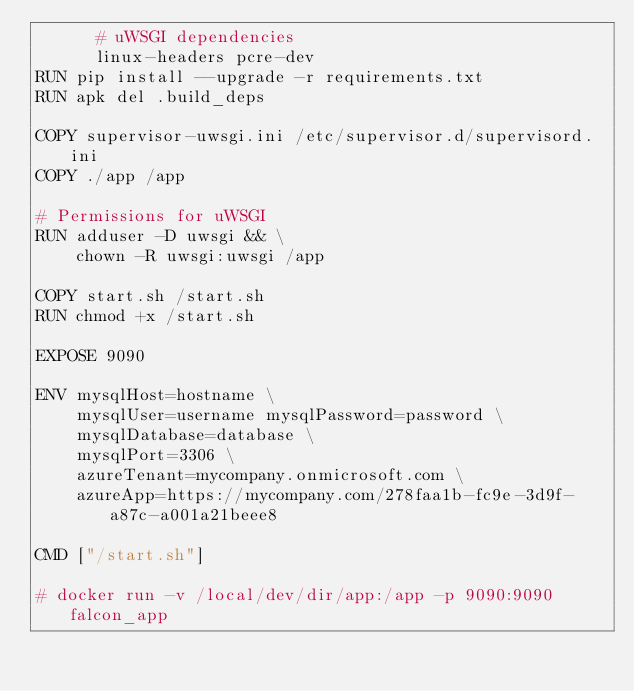<code> <loc_0><loc_0><loc_500><loc_500><_Dockerfile_>      # uWSGI dependencies
      linux-headers pcre-dev
RUN pip install --upgrade -r requirements.txt
RUN apk del .build_deps

COPY supervisor-uwsgi.ini /etc/supervisor.d/supervisord.ini
COPY ./app /app

# Permissions for uWSGI
RUN adduser -D uwsgi && \
    chown -R uwsgi:uwsgi /app

COPY start.sh /start.sh
RUN chmod +x /start.sh

EXPOSE 9090

ENV mysqlHost=hostname \
    mysqlUser=username mysqlPassword=password \
    mysqlDatabase=database \
    mysqlPort=3306 \
    azureTenant=mycompany.onmicrosoft.com \
    azureApp=https://mycompany.com/278faa1b-fc9e-3d9f-a87c-a001a21beee8

CMD ["/start.sh"]

# docker run -v /local/dev/dir/app:/app -p 9090:9090 falcon_app
</code> 